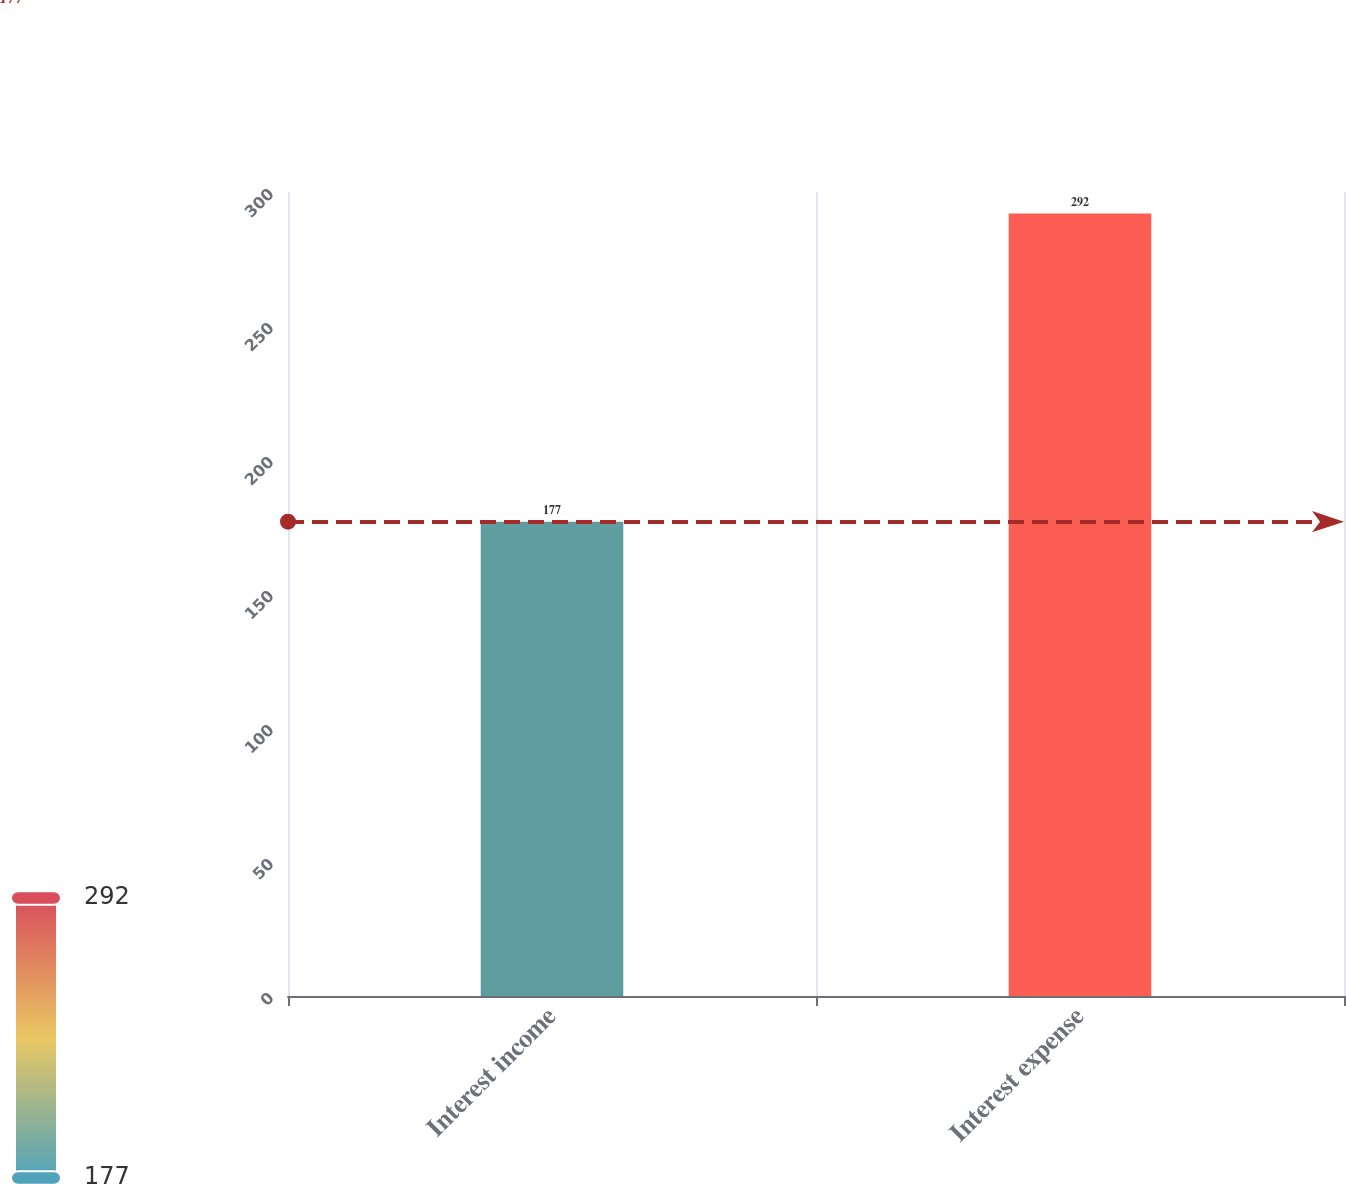<chart> <loc_0><loc_0><loc_500><loc_500><bar_chart><fcel>Interest income<fcel>Interest expense<nl><fcel>177<fcel>292<nl></chart> 